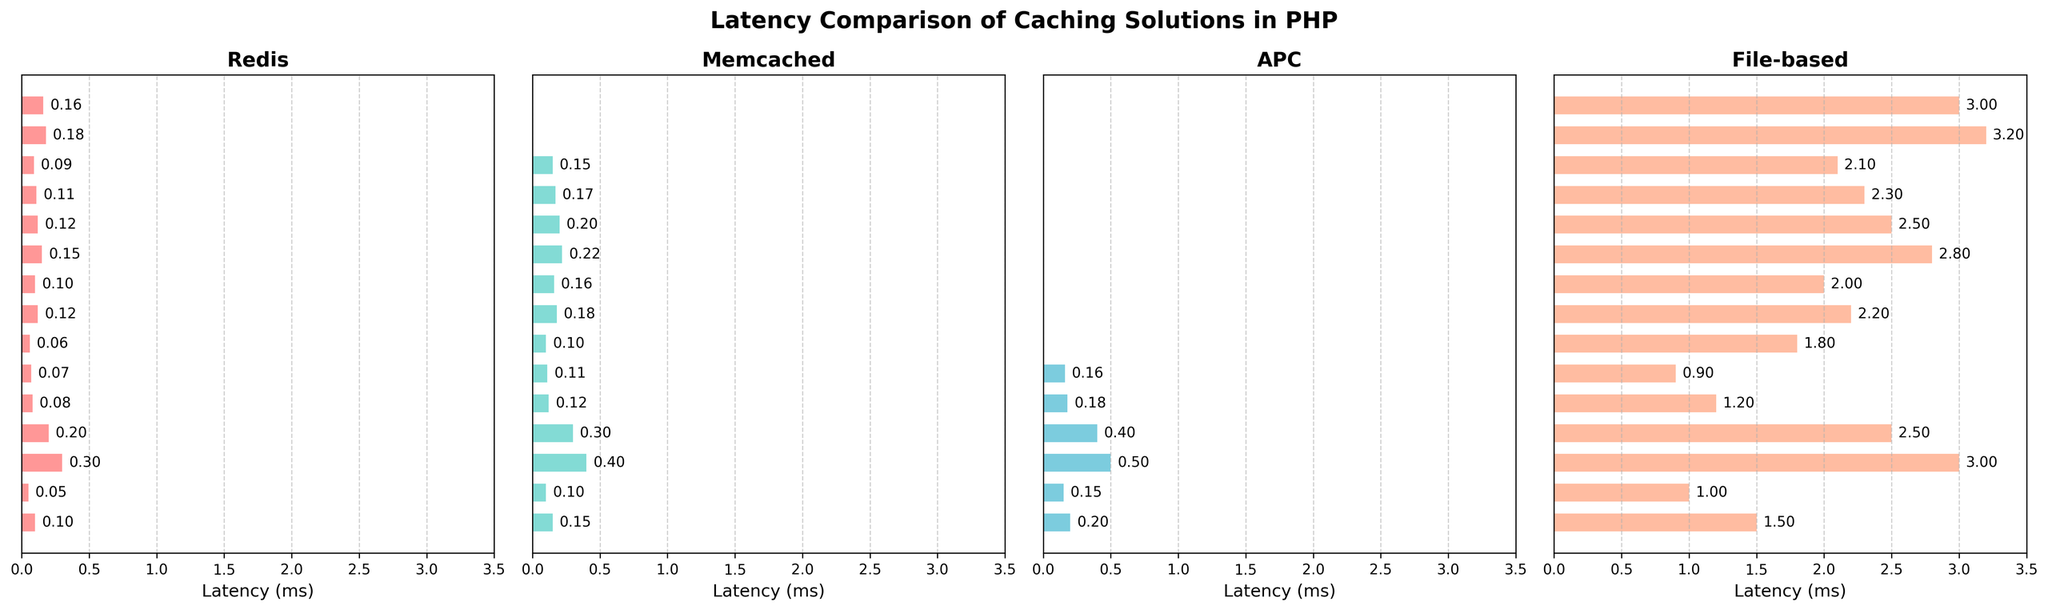Which caching solution has the lowest latency for the "Set small string" operation? By examining the "Set small string" operation across all four caching solutions, Redis has the smallest bar indicating the lowest latency visually.
Answer: Redis Of all the operations, which one has the highest latency in the Redis subplot? By checking the height of bars in the Redis subplot, the "Set large object" operation shows the highest bar.
Answer: Set large object What is the average latency for the "Get small string" operation across all four caching solutions? To get the average, add the latencies from each caching solution for "Get small string": 0.05 (Redis) + 0.1 (Memcached) + 0.15 (APC) + 1.0 (File-based), resulting in 1.3. Then divide by the number of solutions (4), i.e., 1.3 / 4
Answer: 0.325 Which solution has "Expire" operation latency, and how do they compare? "Expire" operation is available in Redis, Memcached, and File-based solutions. Redis has the lowest bar, indicating the least latency, followed by Memcached, and File-based has the highest latency.
Answer: Redis < Memcached < File-based For "Set large object" operation, how much faster is Redis compared to the File-based caching solution? Subtract the latency of Redis from that of File-based for "Set large object": 3.0 (File-based) - 0.3 (Redis) = 2.7 ms, indicating Redis is 2.7 milliseconds faster.
Answer: 2.7 ms In which operation does Memcached have the same latency as Redis, and what is that latency? Check the bars of each operation in Redis and Memcached; the only operation where both bars are at the same height is "Expire" with latency 0.1 ms.
Answer: Expire, 0.1 ms What is the total latency for all operations in the APC subplot? Sum the latencies of all valid (not 'N/A') operations in the APC subplot: 0.2 + 0.15 + 0.5 + 0.4 + 0.18 + 0.16 = 1.59 ms.
Answer: 1.59 ms Which caching solution has the highest latency for "List push" operation? By checking the "List push" operation across the solutions, File-based has the tallest bar indicating the highest latency.
Answer: File-based 